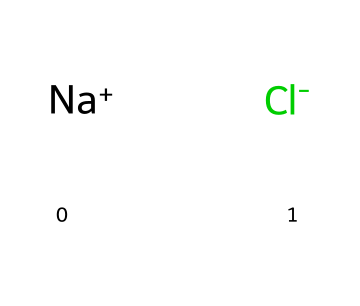What ions are present in sodium chloride? Sodium chloride consists of positively charged sodium ions and negatively charged chloride ions, as represented by [Na+] and [Cl-].
Answer: sodium and chloride How many types of atoms are there in this compound? The compound contains two types of atoms: sodium and chlorine. Each ion provides a unique atomic species to the structure.
Answer: two What type of bond exists between sodium and chloride? The bond in sodium chloride is an ionic bond, formed due to the electrostatic attraction between the positively charged sodium ions and negatively charged chloride ions.
Answer: ionic bond What is the total number of atoms in sodium chloride? Sodium chloride consists of one sodium atom and one chlorine atom, leading to a total count of two atoms in the compound.
Answer: two Is sodium chloride an electrolyte? Sodium chloride disassociates into ions when dissolved in water, allowing it to conduct electricity, which confirms that it is indeed classified as an electrolyte.
Answer: yes What can be inferred about the solubility of sodium chloride in water? Since sodium chloride dissociates into its constituent ions when placed in water, this suggests that it is soluble in water, which is a characteristic property of many electrolytes.
Answer: soluble 